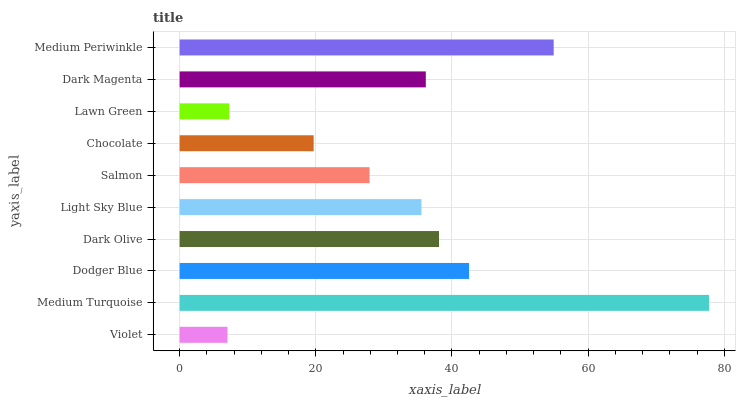Is Violet the minimum?
Answer yes or no. Yes. Is Medium Turquoise the maximum?
Answer yes or no. Yes. Is Dodger Blue the minimum?
Answer yes or no. No. Is Dodger Blue the maximum?
Answer yes or no. No. Is Medium Turquoise greater than Dodger Blue?
Answer yes or no. Yes. Is Dodger Blue less than Medium Turquoise?
Answer yes or no. Yes. Is Dodger Blue greater than Medium Turquoise?
Answer yes or no. No. Is Medium Turquoise less than Dodger Blue?
Answer yes or no. No. Is Dark Magenta the high median?
Answer yes or no. Yes. Is Light Sky Blue the low median?
Answer yes or no. Yes. Is Medium Turquoise the high median?
Answer yes or no. No. Is Salmon the low median?
Answer yes or no. No. 